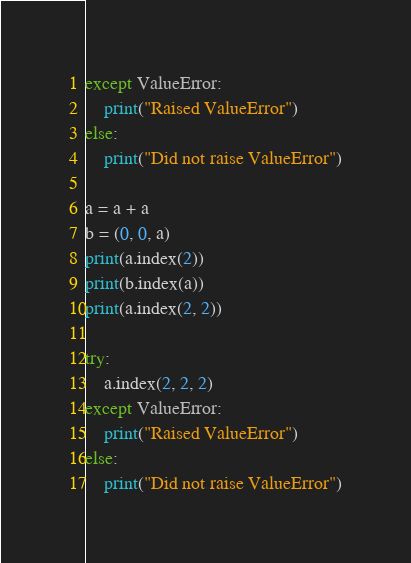<code> <loc_0><loc_0><loc_500><loc_500><_Python_>except ValueError:
    print("Raised ValueError")
else:
    print("Did not raise ValueError")

a = a + a
b = (0, 0, a)
print(a.index(2))
print(b.index(a))
print(a.index(2, 2))

try:
    a.index(2, 2, 2)
except ValueError:
    print("Raised ValueError")
else:
    print("Did not raise ValueError")
</code> 